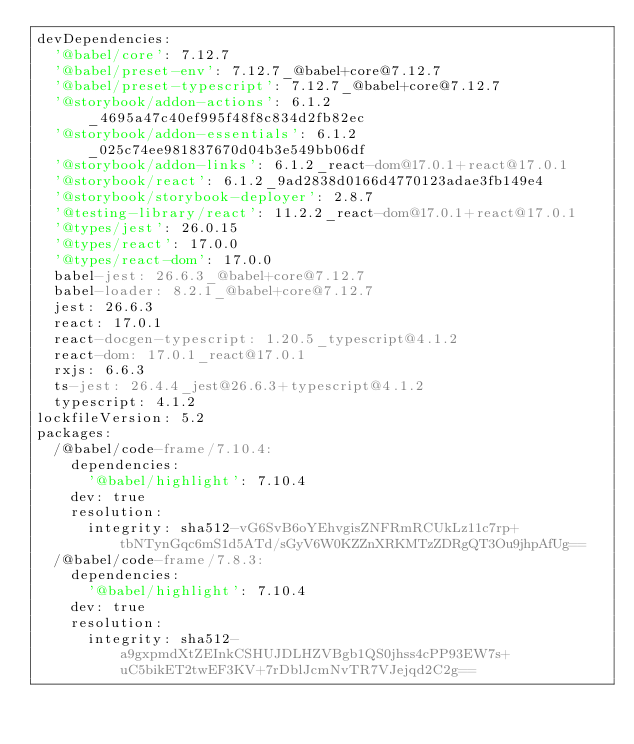Convert code to text. <code><loc_0><loc_0><loc_500><loc_500><_YAML_>devDependencies:
  '@babel/core': 7.12.7
  '@babel/preset-env': 7.12.7_@babel+core@7.12.7
  '@babel/preset-typescript': 7.12.7_@babel+core@7.12.7
  '@storybook/addon-actions': 6.1.2_4695a47c40ef995f48f8c834d2fb82ec
  '@storybook/addon-essentials': 6.1.2_025c74ee981837670d04b3e549bb06df
  '@storybook/addon-links': 6.1.2_react-dom@17.0.1+react@17.0.1
  '@storybook/react': 6.1.2_9ad2838d0166d4770123adae3fb149e4
  '@storybook/storybook-deployer': 2.8.7
  '@testing-library/react': 11.2.2_react-dom@17.0.1+react@17.0.1
  '@types/jest': 26.0.15
  '@types/react': 17.0.0
  '@types/react-dom': 17.0.0
  babel-jest: 26.6.3_@babel+core@7.12.7
  babel-loader: 8.2.1_@babel+core@7.12.7
  jest: 26.6.3
  react: 17.0.1
  react-docgen-typescript: 1.20.5_typescript@4.1.2
  react-dom: 17.0.1_react@17.0.1
  rxjs: 6.6.3
  ts-jest: 26.4.4_jest@26.6.3+typescript@4.1.2
  typescript: 4.1.2
lockfileVersion: 5.2
packages:
  /@babel/code-frame/7.10.4:
    dependencies:
      '@babel/highlight': 7.10.4
    dev: true
    resolution:
      integrity: sha512-vG6SvB6oYEhvgisZNFRmRCUkLz11c7rp+tbNTynGqc6mS1d5ATd/sGyV6W0KZZnXRKMTzZDRgQT3Ou9jhpAfUg==
  /@babel/code-frame/7.8.3:
    dependencies:
      '@babel/highlight': 7.10.4
    dev: true
    resolution:
      integrity: sha512-a9gxpmdXtZEInkCSHUJDLHZVBgb1QS0jhss4cPP93EW7s+uC5bikET2twEF3KV+7rDblJcmNvTR7VJejqd2C2g==</code> 